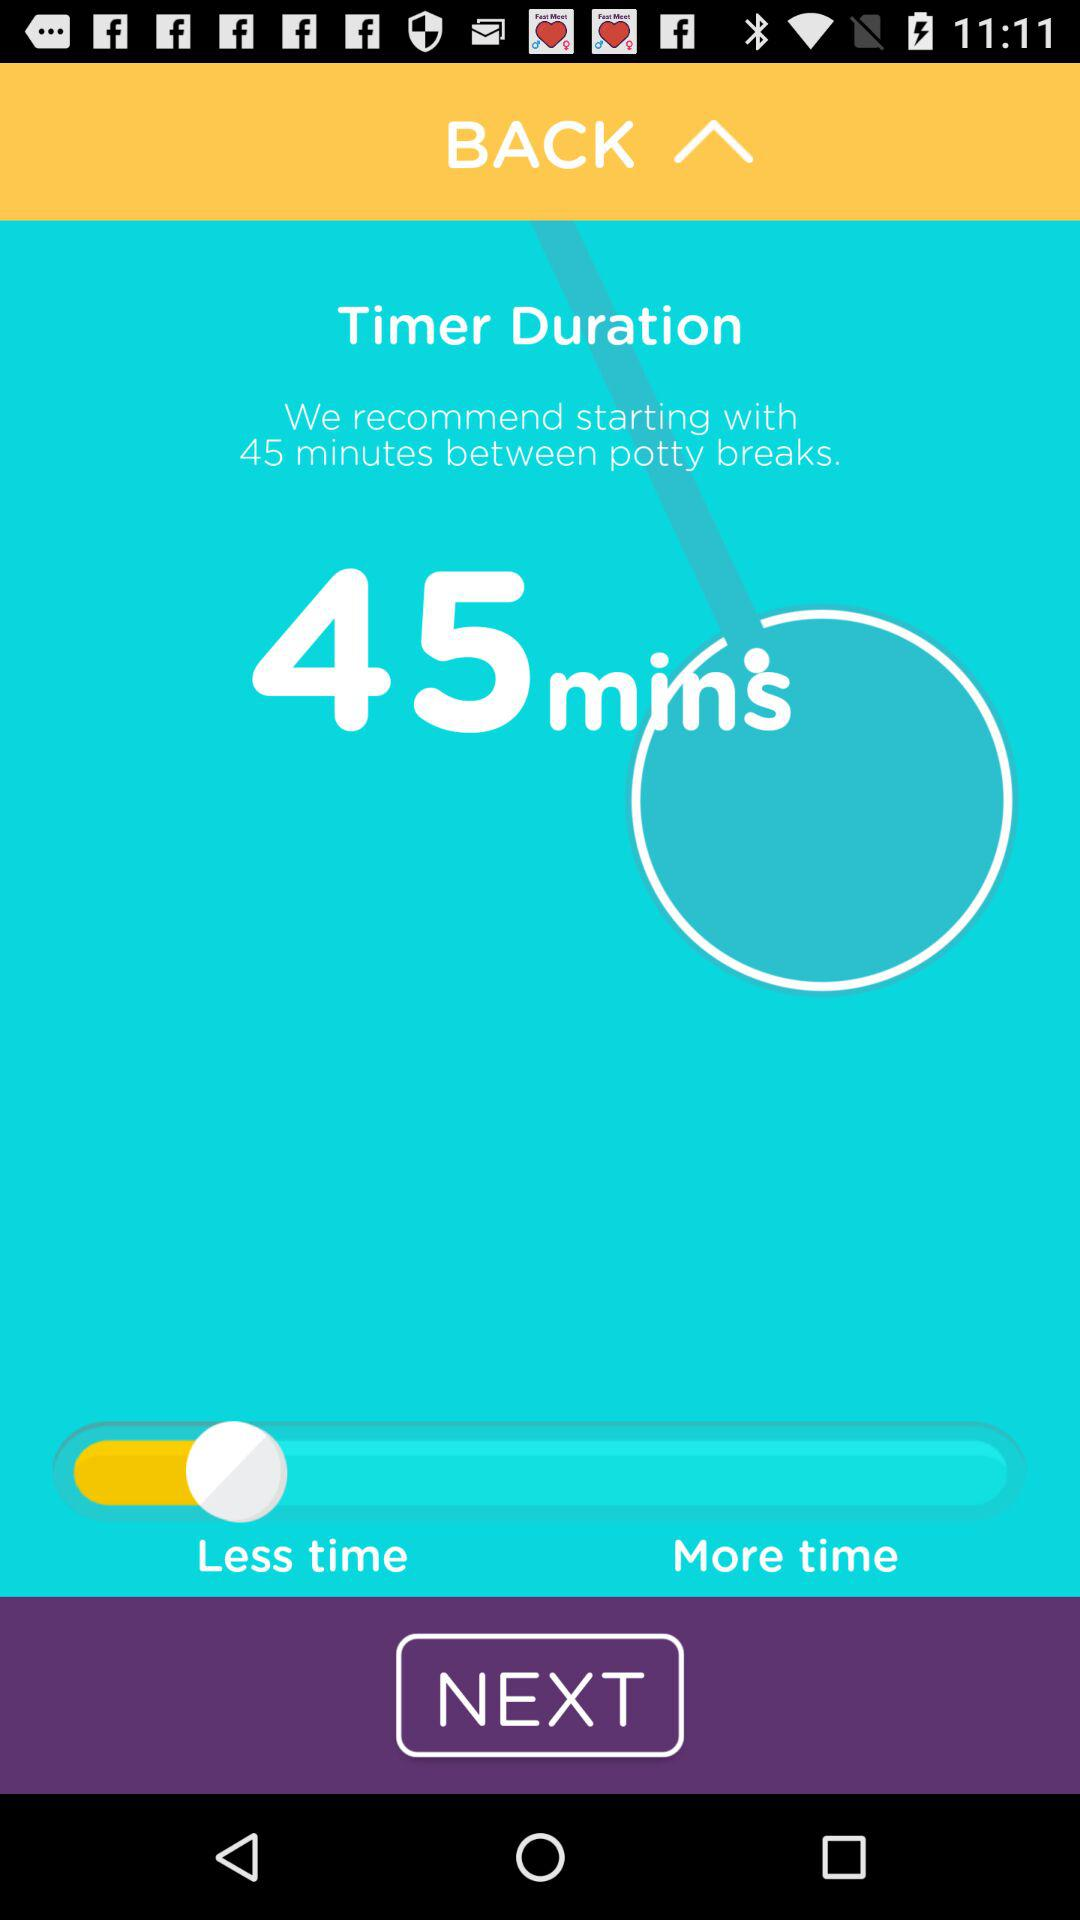What is the time duration? The time duration is 45 minutes. 